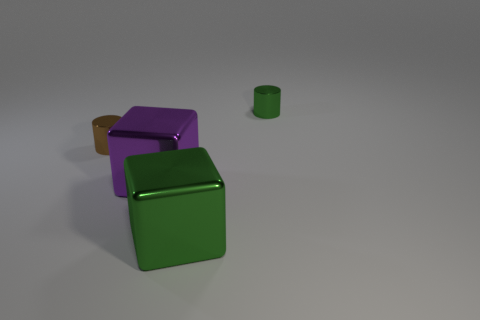What number of metallic things are either big red balls or big purple cubes?
Give a very brief answer. 1. What material is the tiny cylinder that is on the right side of the brown shiny cylinder?
Ensure brevity in your answer.  Metal. What number of objects are small green cylinders or green shiny objects that are in front of the small green cylinder?
Keep it short and to the point. 2. What is the size of the other metallic thing that is the same shape as the tiny brown metallic object?
Give a very brief answer. Small. There is a brown object; are there any large metallic blocks in front of it?
Provide a succinct answer. Yes. There is a small metal cylinder behind the brown metallic cylinder; does it have the same color as the large object that is to the right of the big purple block?
Offer a terse response. Yes. Is there a green object of the same shape as the brown shiny thing?
Make the answer very short. Yes. The shiny cylinder that is to the right of the small metal thing that is left of the tiny cylinder on the right side of the tiny brown object is what color?
Provide a succinct answer. Green. Are there an equal number of objects right of the tiny green object and large red objects?
Make the answer very short. Yes. There is a green thing that is behind the brown metallic object; is its size the same as the tiny brown object?
Make the answer very short. Yes. 